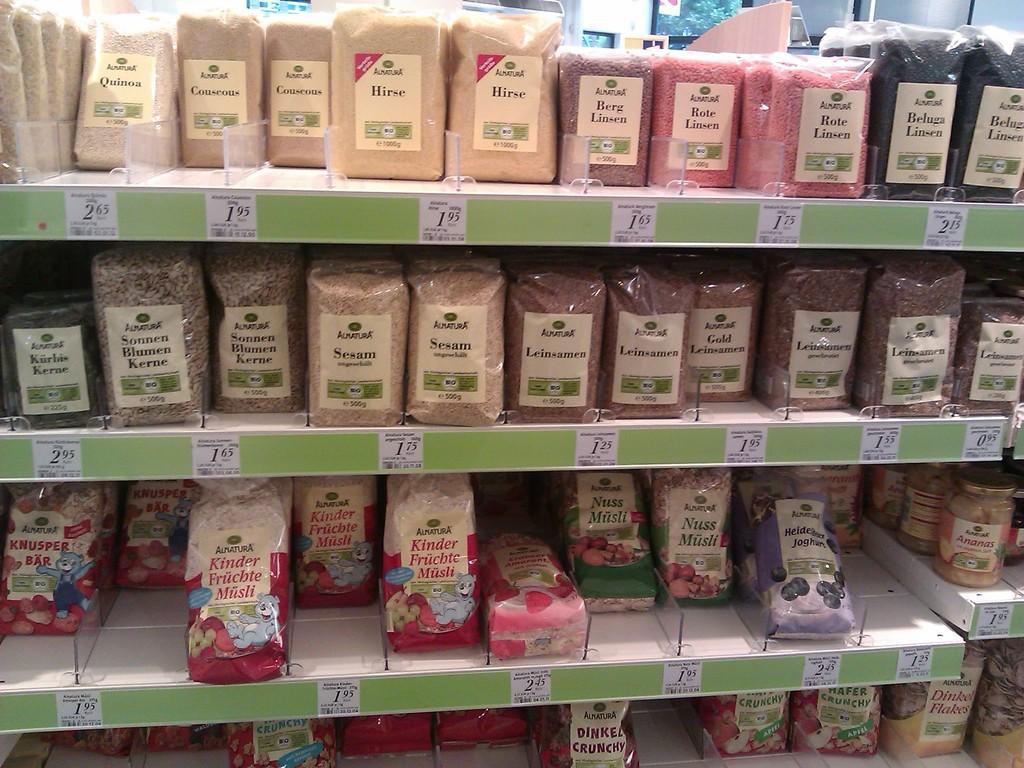How would you summarize this image in a sentence or two? In this image we can see some spices and pulses in the covers and containers placed in the shelves. We can also see some papers with text and numbers on it pasted. 